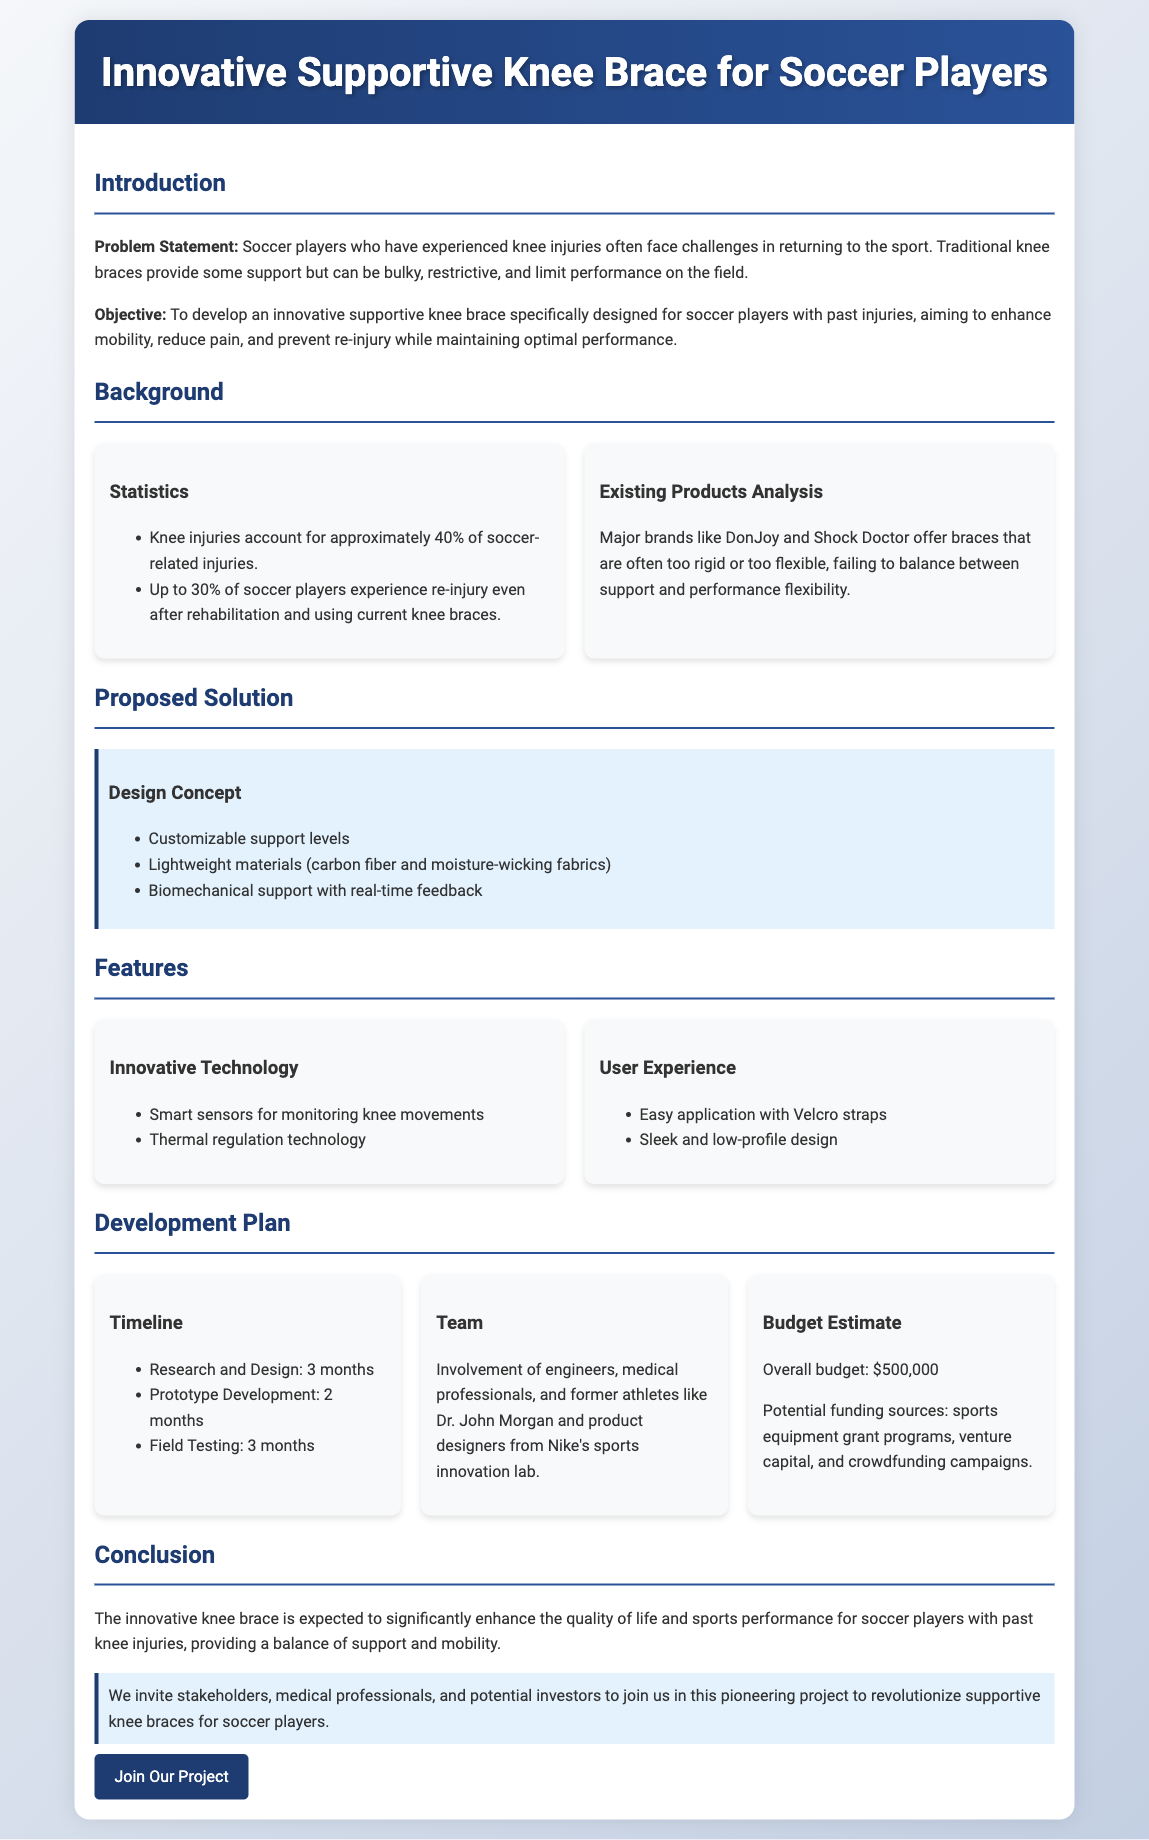what is the main objective of the proposal? The objective is to develop an innovative supportive knee brace specifically designed for soccer players with past injuries, aiming to enhance mobility, reduce pain, and prevent re-injury while maintaining optimal performance.
Answer: to develop an innovative supportive knee brace what percentage of soccer injuries are knee injuries? The document states that knee injuries account for approximately 40% of soccer-related injuries.
Answer: 40% how many months is the research and design phase? The document outlines that the research and design phase will take 3 months.
Answer: 3 months name a major brand that offers traditional knee braces? The document mentions DonJoy and Shock Doctor as major brands that offer knee braces.
Answer: DonJoy what is the overall budget estimate for the project? The document specifies that the overall budget estimate is $500,000.
Answer: $500,000 what feature enhances the knee brace's user experience? The document lists easy application with Velcro straps as a feature that enhances user experience.
Answer: easy application with Velcro straps who is mentioned as part of the development team? Dr. John Morgan is mentioned as part of the development team, along with engineers and medical professionals.
Answer: Dr. John Morgan which material is specified for the brace's lightweight design? The document states that carbon fiber is specified for the brace's lightweight materials.
Answer: carbon fiber how long is the field testing phase expected to last? The document states that the field testing phase is expected to last for 3 months.
Answer: 3 months 